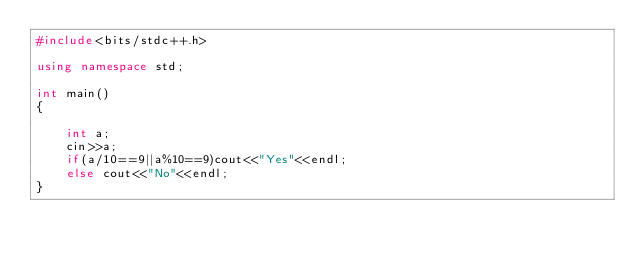Convert code to text. <code><loc_0><loc_0><loc_500><loc_500><_C++_>#include<bits/stdc++.h>

using namespace std;

int main()
{

    int a;
    cin>>a;
    if(a/10==9||a%10==9)cout<<"Yes"<<endl;
    else cout<<"No"<<endl;
}</code> 